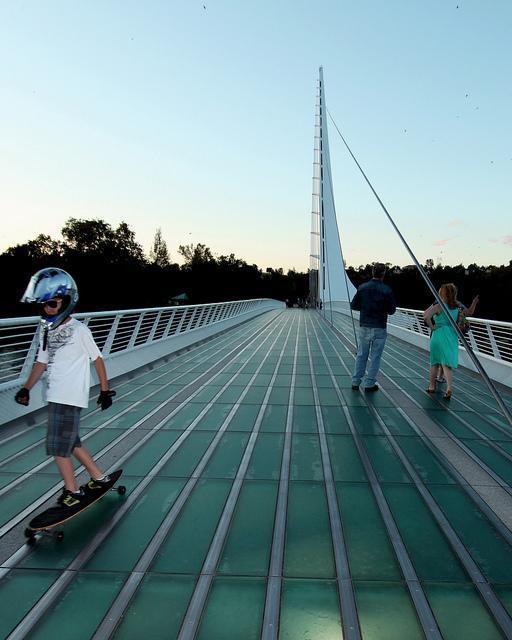How many people are there?
Give a very brief answer. 3. How many horses are pulling the cart?
Give a very brief answer. 0. 